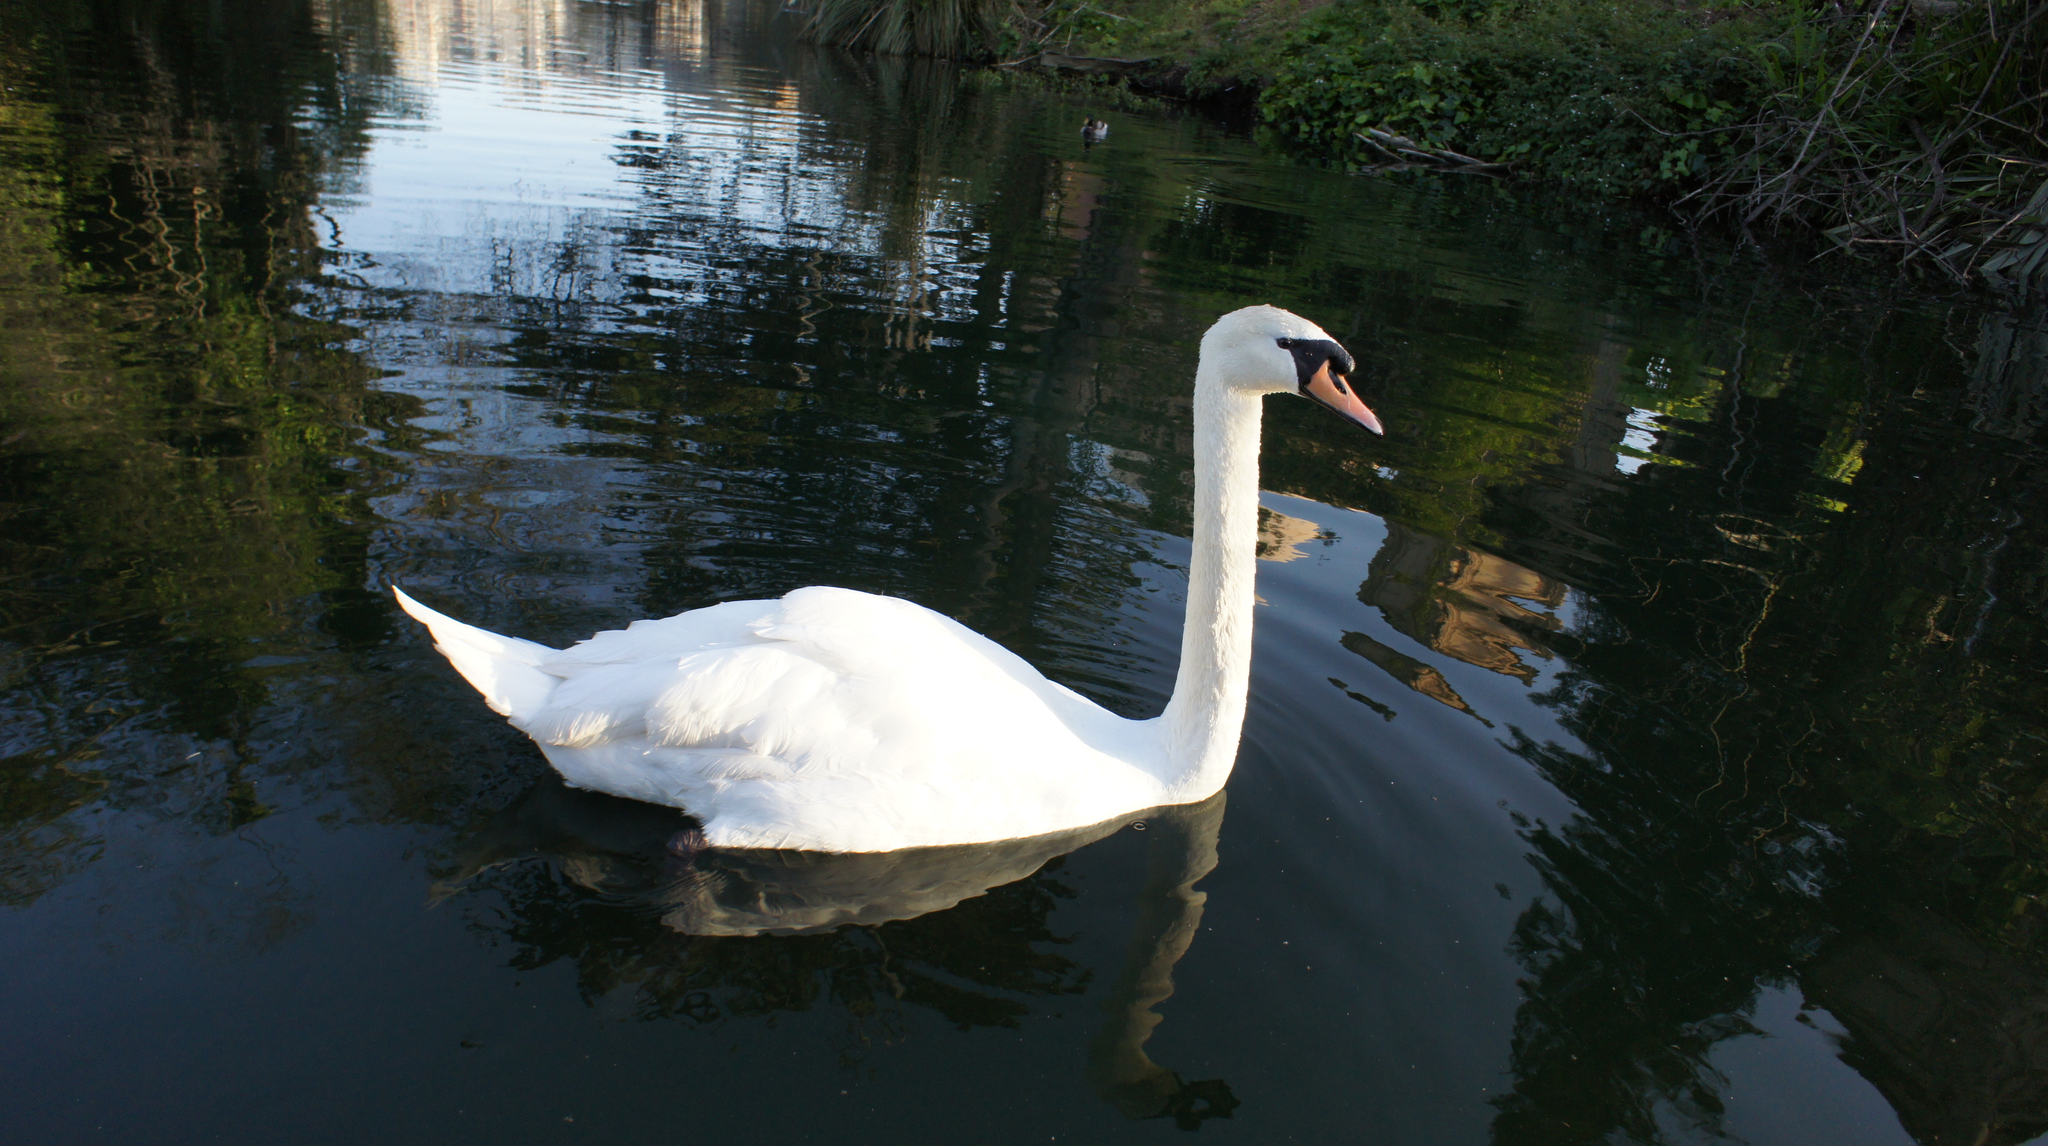Can you describe this image briefly? In this picture there is a white color swan on the water. At the back there are trees. At the bottom there is water and there are reflections of trees and there is reflection of sky and swan on the water. 